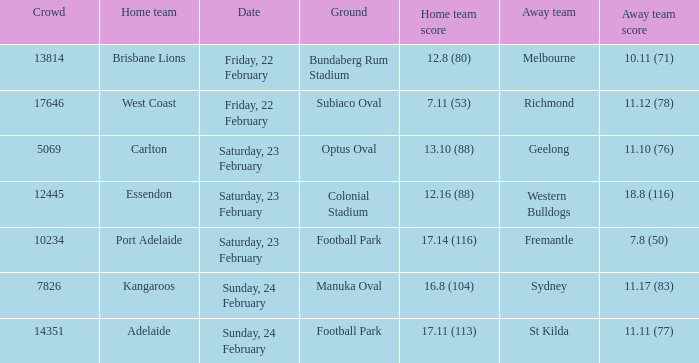What score did the away team receive against home team Port Adelaide? 7.8 (50). 